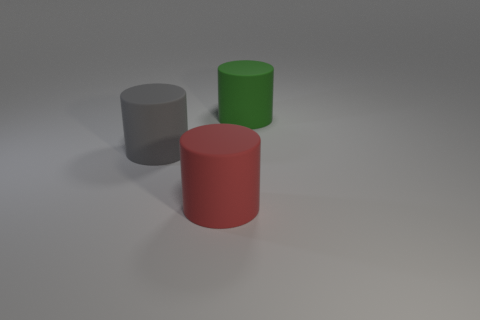There is a big gray object that is the same shape as the red matte thing; what material is it?
Make the answer very short. Rubber. The thing on the left side of the large thing that is in front of the gray cylinder is what shape?
Ensure brevity in your answer.  Cylinder. Are the big thing that is on the left side of the large red cylinder and the green thing made of the same material?
Make the answer very short. Yes. Is the number of big gray cylinders behind the large red rubber object the same as the number of green objects that are right of the green cylinder?
Give a very brief answer. No. How many matte cylinders are on the left side of the rubber cylinder that is behind the gray rubber cylinder?
Ensure brevity in your answer.  2. There is a gray cylinder that is the same size as the red rubber object; what is it made of?
Offer a terse response. Rubber. The object behind the cylinder to the left of the large thing that is in front of the big gray cylinder is what shape?
Ensure brevity in your answer.  Cylinder. What shape is the red object that is the same size as the gray cylinder?
Give a very brief answer. Cylinder. How many big objects are in front of the large cylinder that is in front of the big object that is on the left side of the big red matte thing?
Offer a terse response. 0. Is the number of cylinders left of the gray object greater than the number of big rubber objects that are behind the red thing?
Keep it short and to the point. No. 